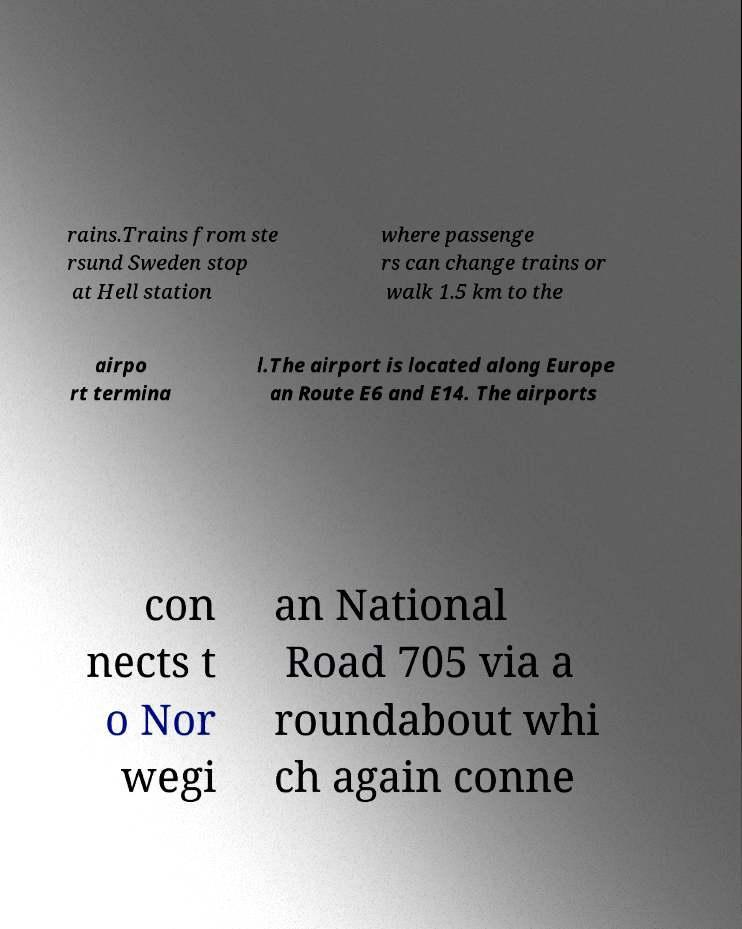Could you extract and type out the text from this image? rains.Trains from ste rsund Sweden stop at Hell station where passenge rs can change trains or walk 1.5 km to the airpo rt termina l.The airport is located along Europe an Route E6 and E14. The airports con nects t o Nor wegi an National Road 705 via a roundabout whi ch again conne 